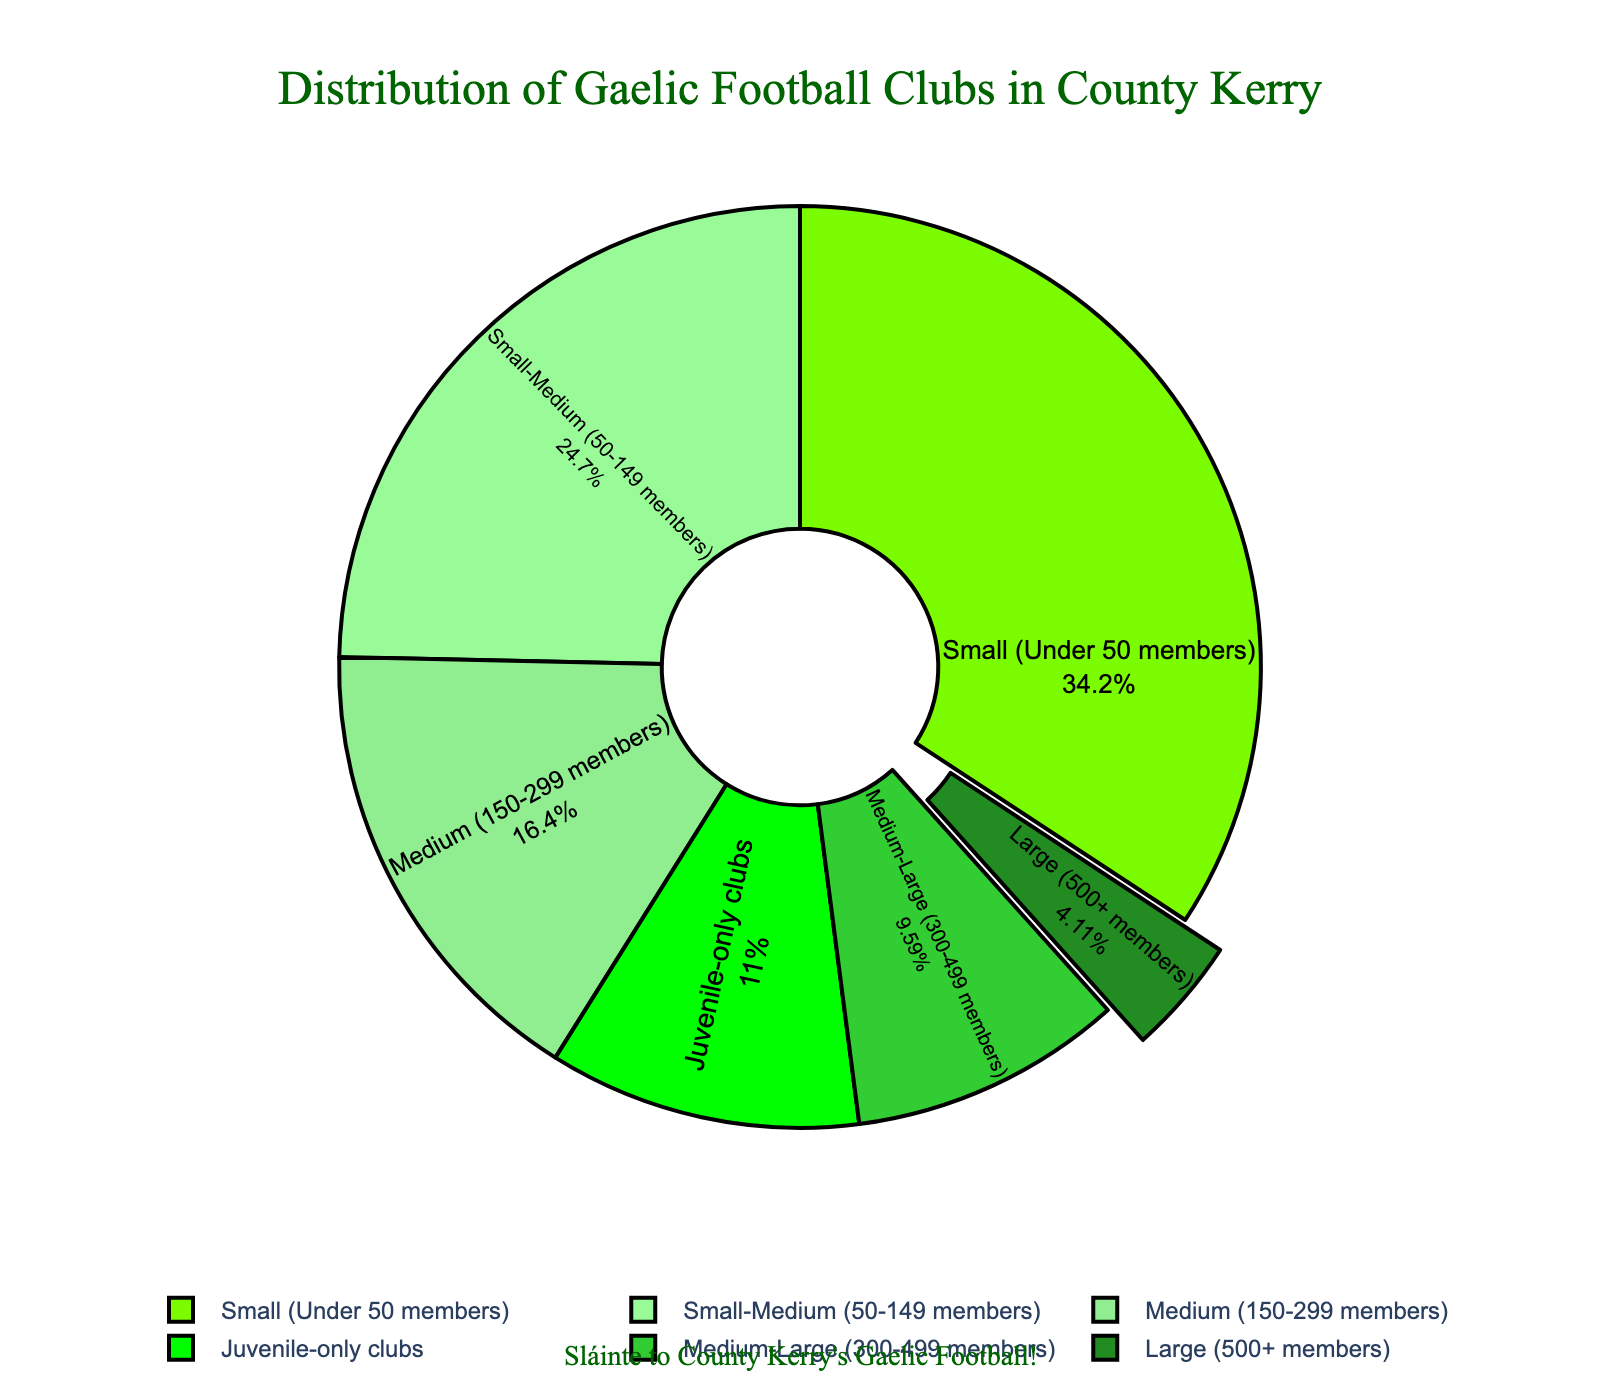Which club size has the most clubs? Look at the section of the pie chart that takes up the largest area. The section labeled with the highest percentage and largest area belongs to the Small (Under 50 members) category.
Answer: Small (Under 50 members) Which club size has the least clubs? Identify the section of the pie chart that takes the smallest area. The section labeled as Large (500+ members) takes up the smallest area.
Answer: Large (500+ members) How many more clubs are Small-Medium compared to Medium-Large? Compare the number of clubs in each size. Small-Medium has 18 clubs and Medium-Large has 7 clubs. Subtract 7 from 18.
Answer: 11 What percentage of clubs are either Small-Medium or Small? Combine the percentages of the Small-Medium and Small categories. Small-Medium is around 28% and Small is around 39%. Add these two percentages together: 28% + 39%.
Answer: 67% How much larger is the total number of Medium and Small clubs compared to Large and Medium-Large clubs? Sum the number of Medium and Small clubs: Medium (12) + Small (25) = 37. Sum the number of Large and Medium-Large clubs: Large (3) + Medium-Large (7) = 10. Find the difference: 37 - 10.
Answer: 27 Which color represents the Juvenile-only clubs? Identify the section of the chart labeled as Juvenile-only clubs and note its color. It should be the last entry in the legend.
Answer: Green How does the distribution of Medium clubs compare to Medium-Large clubs? Look at the size of the sections for Medium clubs (12) and Medium-Large clubs (7). Medium clubs have a larger portion of the pie chart.
Answer: Medium clubs are more than Medium-Large clubs What is the total number of clubs considered Medium-sized (combining Medium and Medium-Large)? Combine the number of Medium (12) and Medium-Large (7) clubs by adding them together: 12 + 7.
Answer: 19 If you combined all the clubs that are Medium and larger (Medium, Medium-Large, Large), what fraction of the total does this represent? Sum the number of clubs in Medium (12), Medium-Large (7), and Large (3) categories: 12 + 7 + 3 = 22. Then, sum the total number of clubs in all categories: 3 + 7 + 12 + 18 + 25 + 8 = 73. Divide the combined number by the total number: 22/73.
Answer: 22/73 Between which two categories is the percentage difference the smallest? Calculate the percentage difference between each pair of adjacent categories by looking at the pie chart. Compare differences and find the smallest one.
Answer: Medium-Large and Juvenile-only (7% difference) 